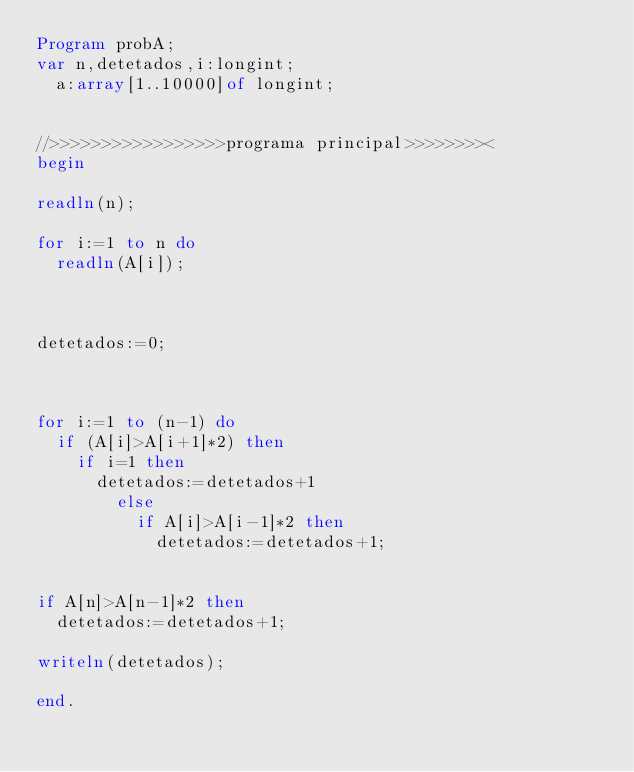Convert code to text. <code><loc_0><loc_0><loc_500><loc_500><_Pascal_>Program probA;
var n,detetados,i:longint;
	a:array[1..10000]of longint;


//>>>>>>>>>>>>>>>>>programa principal>>>>>>>><
begin

readln(n);

for i:=1 to n do
	readln(A[i]);
	


detetados:=0;



for i:=1 to (n-1) do
	if (A[i]>A[i+1]*2) then
		if i=1 then
			detetados:=detetados+1
				else
					if A[i]>A[i-1]*2 then
						detetados:=detetados+1;


if A[n]>A[n-1]*2 then
	detetados:=detetados+1;

writeln(detetados);

end.


</code> 